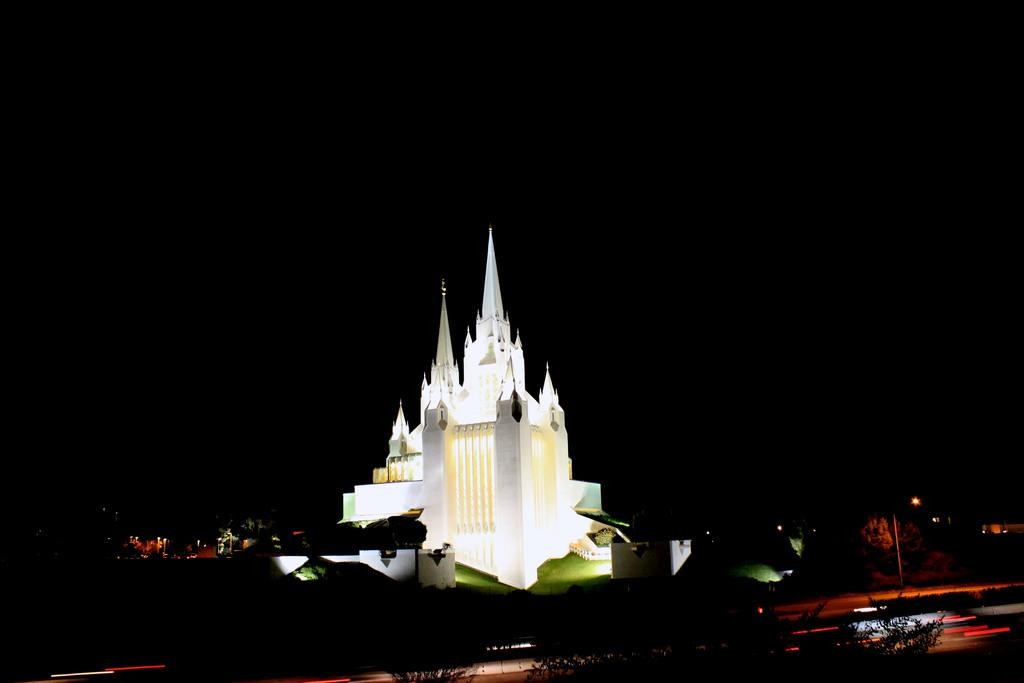Where was the picture taken? The picture was clicked outside. What is the main subject in the center of the image? There is a spire in the center of the image, along with other objects. What can be seen in the background of the image? The background of the image is dark, and there are lights visible. What type of mask is being worn by the spire in the image? There is no mask present in the image, as the spire is an architectural feature and not a person or living being. 